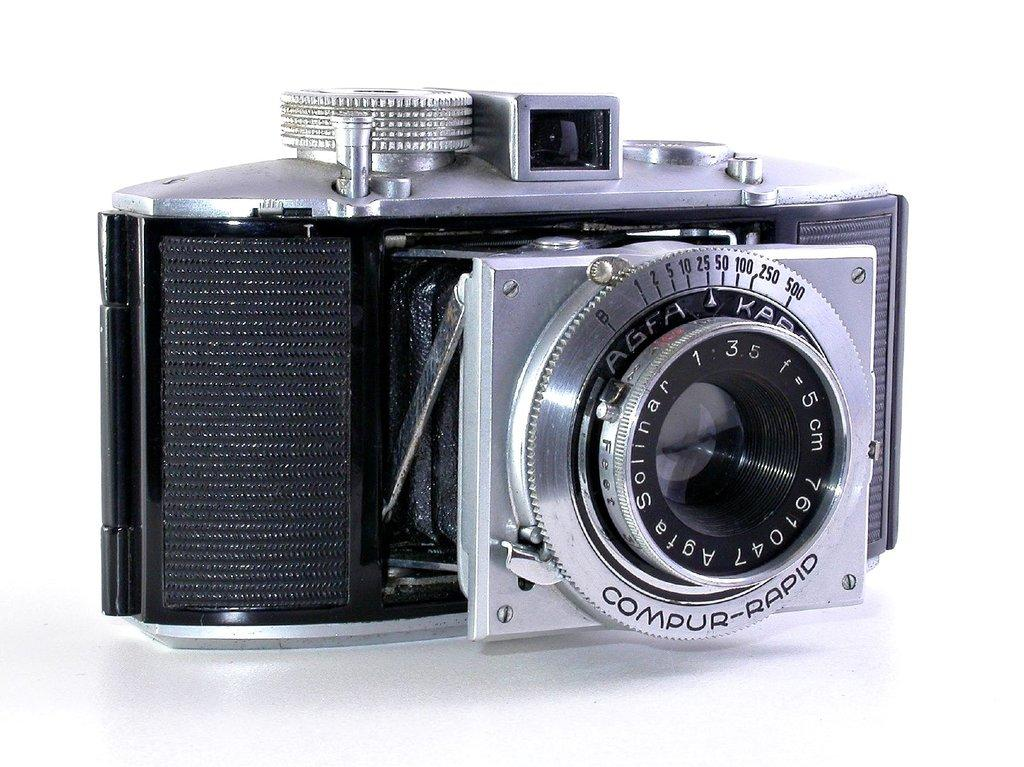What is the main object in the image? There is a camera in the image. What color is the background of the image? The background of the image is white. What type of brass instrument is being played in the image? There is no brass instrument or any musical instrument present in the image; it only features a camera. What color is the machine in the image? There is no machine present in the image; it only features a camera and a white background. 